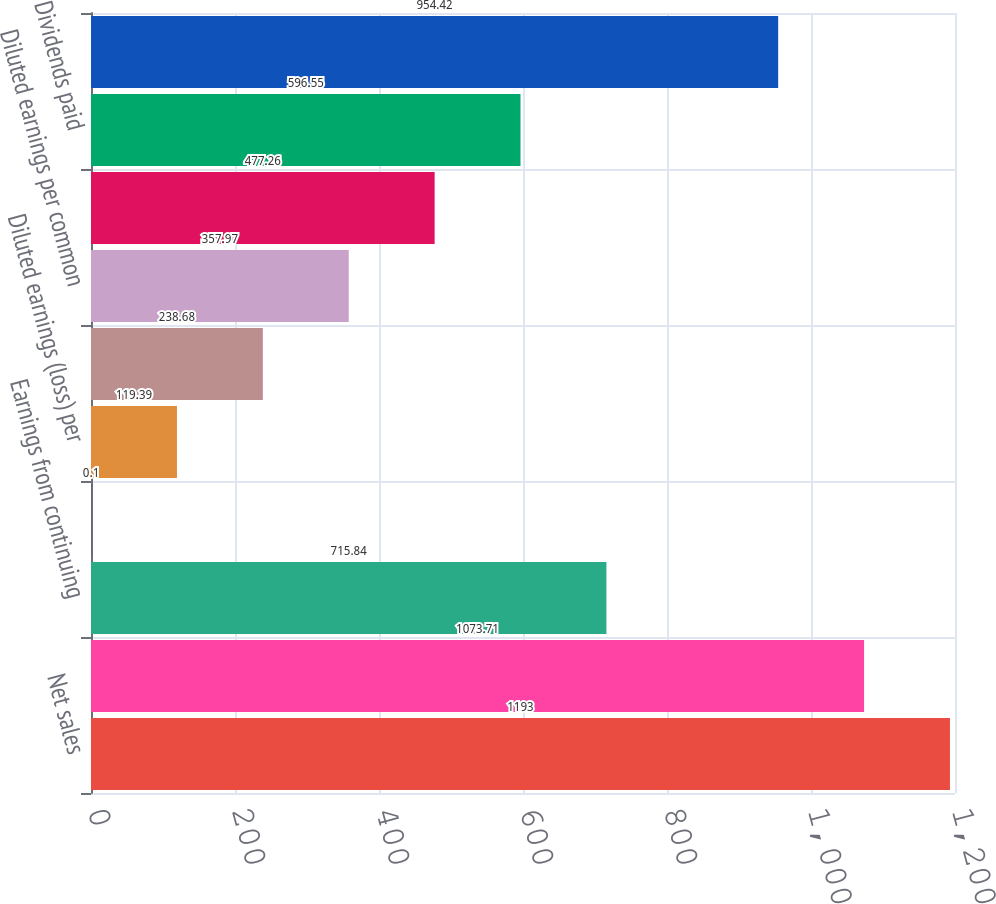<chart> <loc_0><loc_0><loc_500><loc_500><bar_chart><fcel>Net sales<fcel>Costs of sales<fcel>Earnings from continuing<fcel>Basic earnings (loss) per<fcel>Diluted earnings (loss) per<fcel>Basic earnings per common<fcel>Diluted earnings per common<fcel>Dividends declared<fcel>Dividends paid<fcel>High<nl><fcel>1193<fcel>1073.71<fcel>715.84<fcel>0.1<fcel>119.39<fcel>238.68<fcel>357.97<fcel>477.26<fcel>596.55<fcel>954.42<nl></chart> 